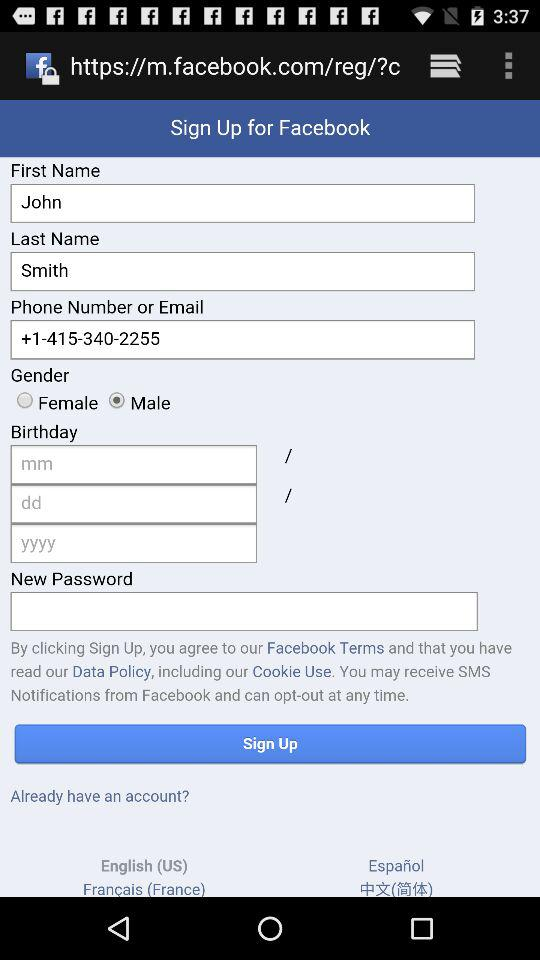How many languages are available for the sign up form?
Answer the question using a single word or phrase. 4 